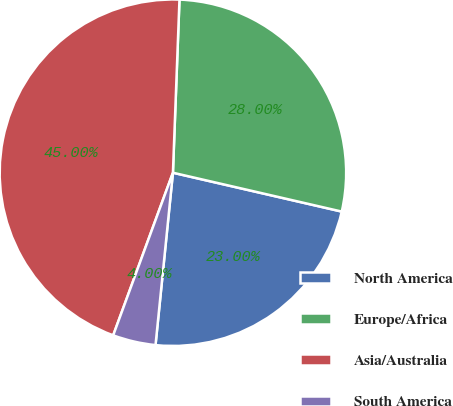Convert chart to OTSL. <chart><loc_0><loc_0><loc_500><loc_500><pie_chart><fcel>North America<fcel>Europe/Africa<fcel>Asia/Australia<fcel>South America<nl><fcel>23.0%<fcel>28.0%<fcel>45.0%<fcel>4.0%<nl></chart> 